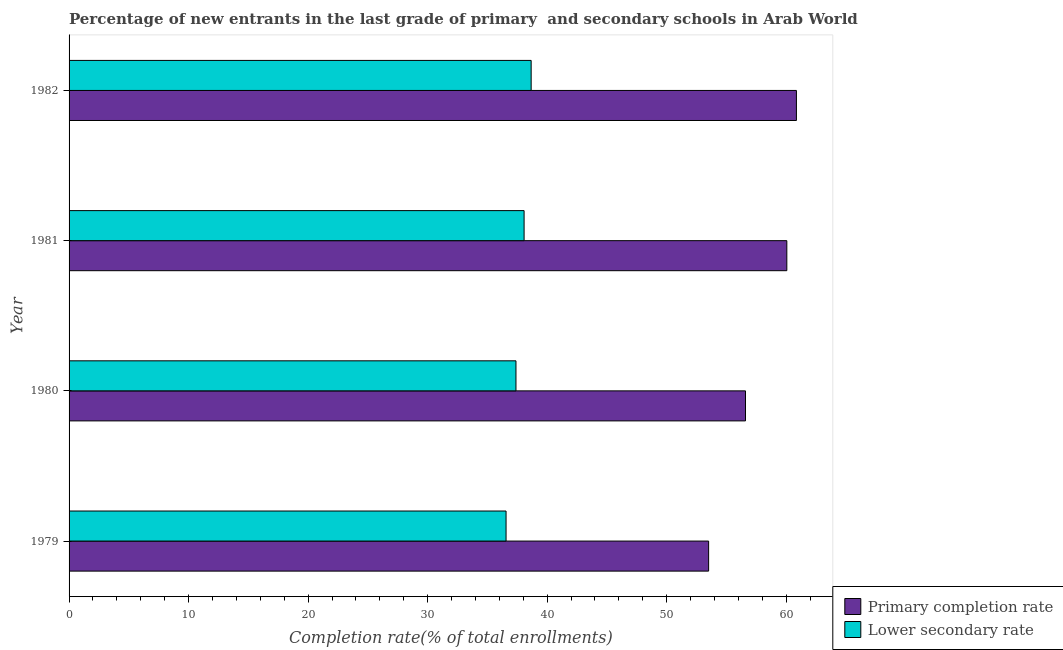Are the number of bars per tick equal to the number of legend labels?
Your answer should be compact. Yes. How many bars are there on the 2nd tick from the top?
Provide a short and direct response. 2. How many bars are there on the 2nd tick from the bottom?
Keep it short and to the point. 2. What is the label of the 1st group of bars from the top?
Your response must be concise. 1982. What is the completion rate in primary schools in 1981?
Make the answer very short. 60.06. Across all years, what is the maximum completion rate in secondary schools?
Offer a very short reply. 38.66. Across all years, what is the minimum completion rate in secondary schools?
Offer a terse response. 36.56. In which year was the completion rate in primary schools maximum?
Give a very brief answer. 1982. In which year was the completion rate in primary schools minimum?
Give a very brief answer. 1979. What is the total completion rate in secondary schools in the graph?
Ensure brevity in your answer.  150.69. What is the difference between the completion rate in secondary schools in 1981 and that in 1982?
Your answer should be very brief. -0.59. What is the difference between the completion rate in primary schools in 1981 and the completion rate in secondary schools in 1980?
Your response must be concise. 22.66. What is the average completion rate in secondary schools per year?
Give a very brief answer. 37.67. In the year 1981, what is the difference between the completion rate in primary schools and completion rate in secondary schools?
Offer a terse response. 21.98. In how many years, is the completion rate in secondary schools greater than 34 %?
Provide a succinct answer. 4. What is the ratio of the completion rate in secondary schools in 1979 to that in 1981?
Ensure brevity in your answer.  0.96. Is the difference between the completion rate in primary schools in 1979 and 1980 greater than the difference between the completion rate in secondary schools in 1979 and 1980?
Offer a terse response. No. What is the difference between the highest and the second highest completion rate in primary schools?
Give a very brief answer. 0.8. What does the 2nd bar from the top in 1981 represents?
Ensure brevity in your answer.  Primary completion rate. What does the 2nd bar from the bottom in 1979 represents?
Provide a succinct answer. Lower secondary rate. How many years are there in the graph?
Your answer should be very brief. 4. What is the difference between two consecutive major ticks on the X-axis?
Provide a succinct answer. 10. How many legend labels are there?
Your answer should be very brief. 2. How are the legend labels stacked?
Provide a short and direct response. Vertical. What is the title of the graph?
Your answer should be compact. Percentage of new entrants in the last grade of primary  and secondary schools in Arab World. Does "Pregnant women" appear as one of the legend labels in the graph?
Your answer should be compact. No. What is the label or title of the X-axis?
Ensure brevity in your answer.  Completion rate(% of total enrollments). What is the Completion rate(% of total enrollments) of Primary completion rate in 1979?
Offer a terse response. 53.51. What is the Completion rate(% of total enrollments) in Lower secondary rate in 1979?
Your answer should be compact. 36.56. What is the Completion rate(% of total enrollments) in Primary completion rate in 1980?
Ensure brevity in your answer.  56.6. What is the Completion rate(% of total enrollments) of Lower secondary rate in 1980?
Ensure brevity in your answer.  37.39. What is the Completion rate(% of total enrollments) of Primary completion rate in 1981?
Provide a succinct answer. 60.06. What is the Completion rate(% of total enrollments) of Lower secondary rate in 1981?
Provide a short and direct response. 38.07. What is the Completion rate(% of total enrollments) of Primary completion rate in 1982?
Your answer should be compact. 60.86. What is the Completion rate(% of total enrollments) in Lower secondary rate in 1982?
Make the answer very short. 38.66. Across all years, what is the maximum Completion rate(% of total enrollments) of Primary completion rate?
Offer a terse response. 60.86. Across all years, what is the maximum Completion rate(% of total enrollments) of Lower secondary rate?
Your answer should be very brief. 38.66. Across all years, what is the minimum Completion rate(% of total enrollments) in Primary completion rate?
Provide a short and direct response. 53.51. Across all years, what is the minimum Completion rate(% of total enrollments) of Lower secondary rate?
Your response must be concise. 36.56. What is the total Completion rate(% of total enrollments) in Primary completion rate in the graph?
Give a very brief answer. 231.02. What is the total Completion rate(% of total enrollments) of Lower secondary rate in the graph?
Make the answer very short. 150.69. What is the difference between the Completion rate(% of total enrollments) in Primary completion rate in 1979 and that in 1980?
Your answer should be very brief. -3.09. What is the difference between the Completion rate(% of total enrollments) of Lower secondary rate in 1979 and that in 1980?
Your answer should be very brief. -0.83. What is the difference between the Completion rate(% of total enrollments) of Primary completion rate in 1979 and that in 1981?
Offer a terse response. -6.54. What is the difference between the Completion rate(% of total enrollments) in Lower secondary rate in 1979 and that in 1981?
Provide a short and direct response. -1.51. What is the difference between the Completion rate(% of total enrollments) of Primary completion rate in 1979 and that in 1982?
Your answer should be compact. -7.35. What is the difference between the Completion rate(% of total enrollments) in Lower secondary rate in 1979 and that in 1982?
Make the answer very short. -2.1. What is the difference between the Completion rate(% of total enrollments) of Primary completion rate in 1980 and that in 1981?
Provide a succinct answer. -3.46. What is the difference between the Completion rate(% of total enrollments) of Lower secondary rate in 1980 and that in 1981?
Offer a very short reply. -0.68. What is the difference between the Completion rate(% of total enrollments) of Primary completion rate in 1980 and that in 1982?
Your answer should be compact. -4.26. What is the difference between the Completion rate(% of total enrollments) of Lower secondary rate in 1980 and that in 1982?
Offer a very short reply. -1.27. What is the difference between the Completion rate(% of total enrollments) in Primary completion rate in 1981 and that in 1982?
Provide a short and direct response. -0.8. What is the difference between the Completion rate(% of total enrollments) in Lower secondary rate in 1981 and that in 1982?
Keep it short and to the point. -0.59. What is the difference between the Completion rate(% of total enrollments) in Primary completion rate in 1979 and the Completion rate(% of total enrollments) in Lower secondary rate in 1980?
Offer a very short reply. 16.12. What is the difference between the Completion rate(% of total enrollments) of Primary completion rate in 1979 and the Completion rate(% of total enrollments) of Lower secondary rate in 1981?
Your answer should be very brief. 15.44. What is the difference between the Completion rate(% of total enrollments) of Primary completion rate in 1979 and the Completion rate(% of total enrollments) of Lower secondary rate in 1982?
Give a very brief answer. 14.85. What is the difference between the Completion rate(% of total enrollments) in Primary completion rate in 1980 and the Completion rate(% of total enrollments) in Lower secondary rate in 1981?
Your answer should be compact. 18.53. What is the difference between the Completion rate(% of total enrollments) of Primary completion rate in 1980 and the Completion rate(% of total enrollments) of Lower secondary rate in 1982?
Your response must be concise. 17.93. What is the difference between the Completion rate(% of total enrollments) in Primary completion rate in 1981 and the Completion rate(% of total enrollments) in Lower secondary rate in 1982?
Offer a very short reply. 21.39. What is the average Completion rate(% of total enrollments) in Primary completion rate per year?
Your response must be concise. 57.76. What is the average Completion rate(% of total enrollments) in Lower secondary rate per year?
Provide a short and direct response. 37.67. In the year 1979, what is the difference between the Completion rate(% of total enrollments) in Primary completion rate and Completion rate(% of total enrollments) in Lower secondary rate?
Give a very brief answer. 16.95. In the year 1980, what is the difference between the Completion rate(% of total enrollments) of Primary completion rate and Completion rate(% of total enrollments) of Lower secondary rate?
Ensure brevity in your answer.  19.2. In the year 1981, what is the difference between the Completion rate(% of total enrollments) in Primary completion rate and Completion rate(% of total enrollments) in Lower secondary rate?
Your answer should be compact. 21.98. In the year 1982, what is the difference between the Completion rate(% of total enrollments) of Primary completion rate and Completion rate(% of total enrollments) of Lower secondary rate?
Offer a terse response. 22.2. What is the ratio of the Completion rate(% of total enrollments) of Primary completion rate in 1979 to that in 1980?
Keep it short and to the point. 0.95. What is the ratio of the Completion rate(% of total enrollments) in Lower secondary rate in 1979 to that in 1980?
Give a very brief answer. 0.98. What is the ratio of the Completion rate(% of total enrollments) of Primary completion rate in 1979 to that in 1981?
Give a very brief answer. 0.89. What is the ratio of the Completion rate(% of total enrollments) in Lower secondary rate in 1979 to that in 1981?
Your answer should be very brief. 0.96. What is the ratio of the Completion rate(% of total enrollments) in Primary completion rate in 1979 to that in 1982?
Provide a succinct answer. 0.88. What is the ratio of the Completion rate(% of total enrollments) in Lower secondary rate in 1979 to that in 1982?
Your answer should be very brief. 0.95. What is the ratio of the Completion rate(% of total enrollments) of Primary completion rate in 1980 to that in 1981?
Your response must be concise. 0.94. What is the ratio of the Completion rate(% of total enrollments) of Lower secondary rate in 1980 to that in 1981?
Make the answer very short. 0.98. What is the ratio of the Completion rate(% of total enrollments) of Lower secondary rate in 1980 to that in 1982?
Offer a terse response. 0.97. What is the ratio of the Completion rate(% of total enrollments) of Primary completion rate in 1981 to that in 1982?
Make the answer very short. 0.99. What is the ratio of the Completion rate(% of total enrollments) of Lower secondary rate in 1981 to that in 1982?
Provide a succinct answer. 0.98. What is the difference between the highest and the second highest Completion rate(% of total enrollments) of Primary completion rate?
Ensure brevity in your answer.  0.8. What is the difference between the highest and the second highest Completion rate(% of total enrollments) in Lower secondary rate?
Provide a succinct answer. 0.59. What is the difference between the highest and the lowest Completion rate(% of total enrollments) in Primary completion rate?
Provide a short and direct response. 7.35. What is the difference between the highest and the lowest Completion rate(% of total enrollments) of Lower secondary rate?
Ensure brevity in your answer.  2.1. 